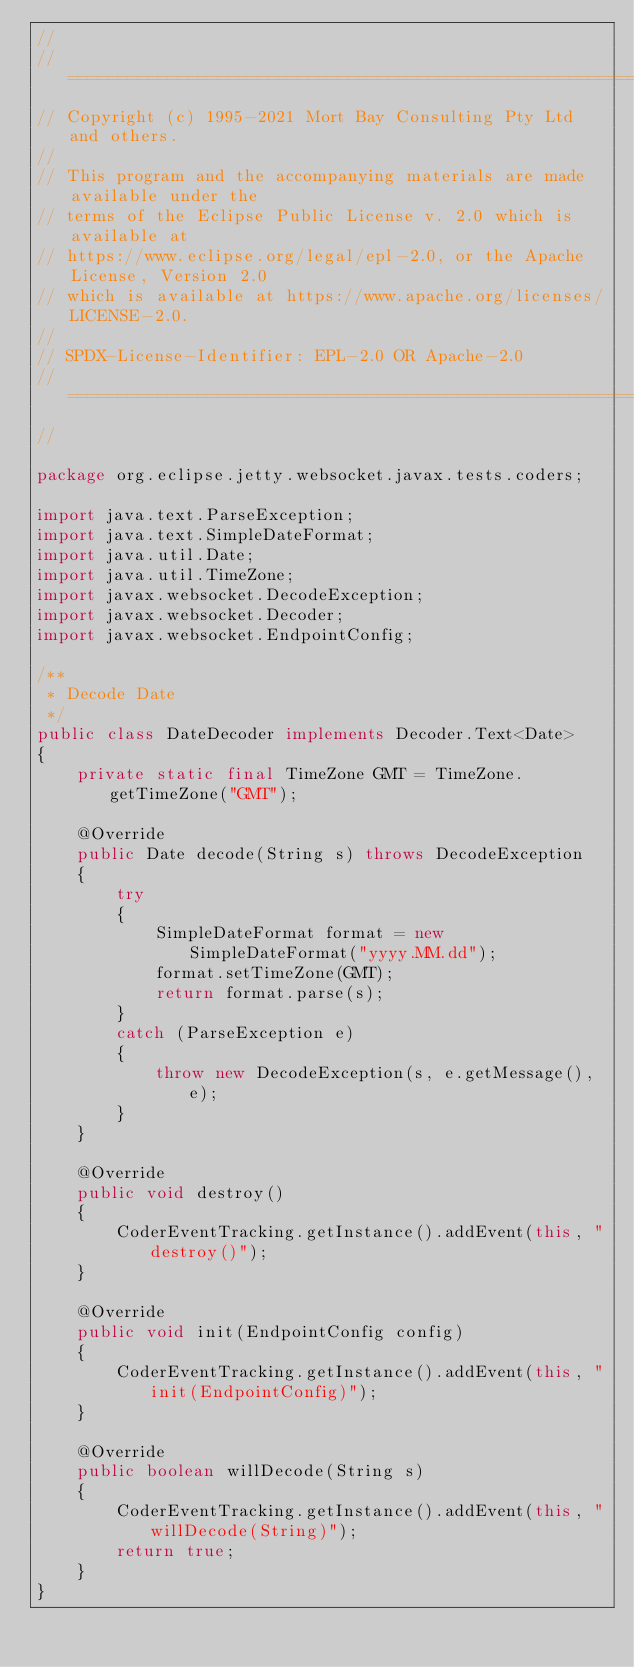Convert code to text. <code><loc_0><loc_0><loc_500><loc_500><_Java_>//
// ========================================================================
// Copyright (c) 1995-2021 Mort Bay Consulting Pty Ltd and others.
//
// This program and the accompanying materials are made available under the
// terms of the Eclipse Public License v. 2.0 which is available at
// https://www.eclipse.org/legal/epl-2.0, or the Apache License, Version 2.0
// which is available at https://www.apache.org/licenses/LICENSE-2.0.
//
// SPDX-License-Identifier: EPL-2.0 OR Apache-2.0
// ========================================================================
//

package org.eclipse.jetty.websocket.javax.tests.coders;

import java.text.ParseException;
import java.text.SimpleDateFormat;
import java.util.Date;
import java.util.TimeZone;
import javax.websocket.DecodeException;
import javax.websocket.Decoder;
import javax.websocket.EndpointConfig;

/**
 * Decode Date
 */
public class DateDecoder implements Decoder.Text<Date>
{
    private static final TimeZone GMT = TimeZone.getTimeZone("GMT");

    @Override
    public Date decode(String s) throws DecodeException
    {
        try
        {
            SimpleDateFormat format = new SimpleDateFormat("yyyy.MM.dd");
            format.setTimeZone(GMT);
            return format.parse(s);
        }
        catch (ParseException e)
        {
            throw new DecodeException(s, e.getMessage(), e);
        }
    }

    @Override
    public void destroy()
    {
        CoderEventTracking.getInstance().addEvent(this, "destroy()");
    }

    @Override
    public void init(EndpointConfig config)
    {
        CoderEventTracking.getInstance().addEvent(this, "init(EndpointConfig)");
    }

    @Override
    public boolean willDecode(String s)
    {
        CoderEventTracking.getInstance().addEvent(this, "willDecode(String)");
        return true;
    }
}
</code> 